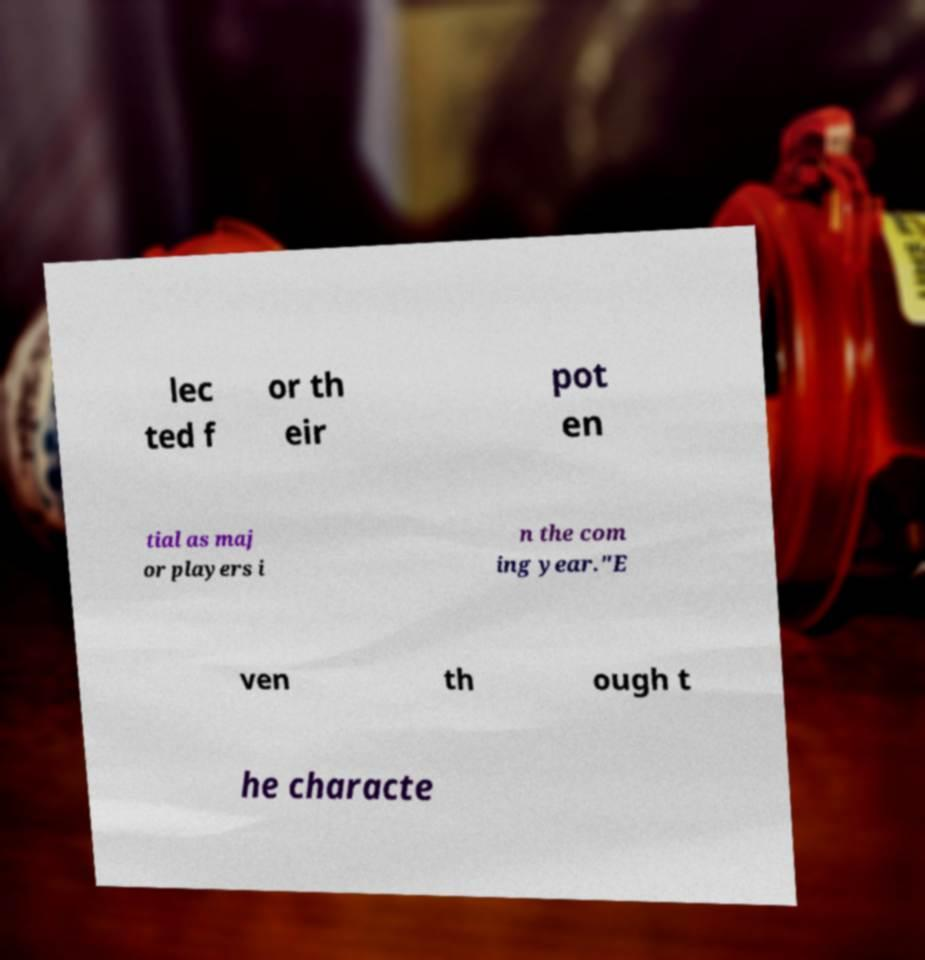There's text embedded in this image that I need extracted. Can you transcribe it verbatim? lec ted f or th eir pot en tial as maj or players i n the com ing year."E ven th ough t he characte 